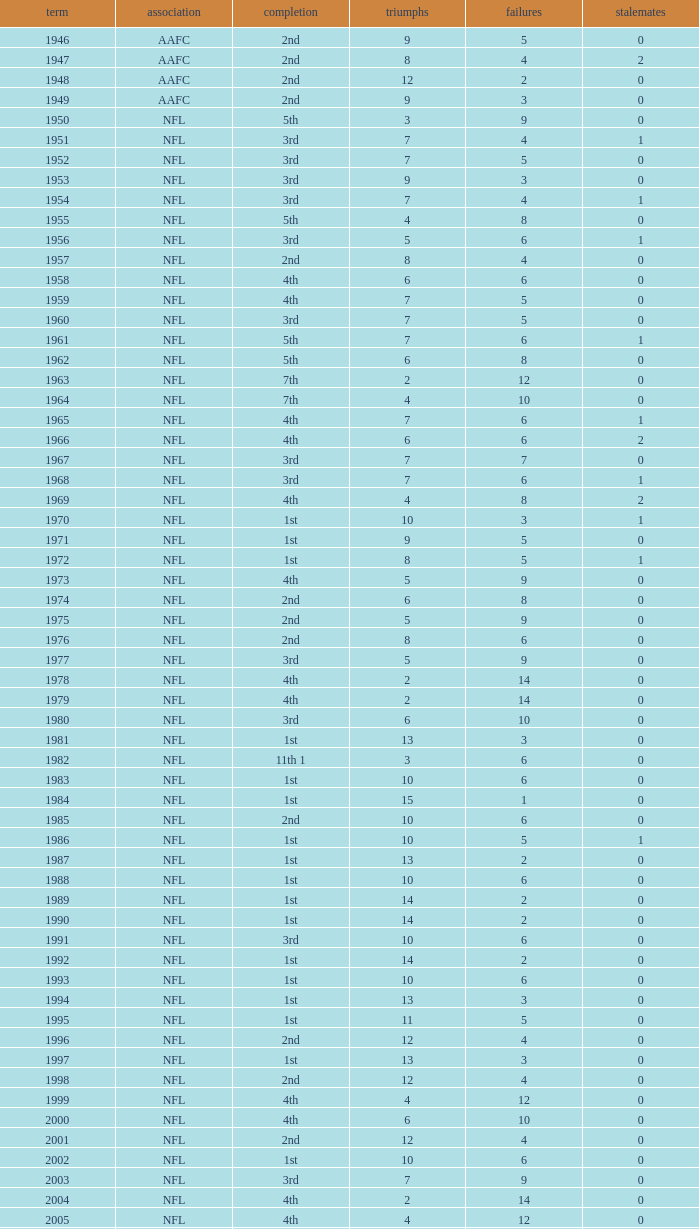What is the losses in the NFL in the 2011 season with less than 13 wins? None. 